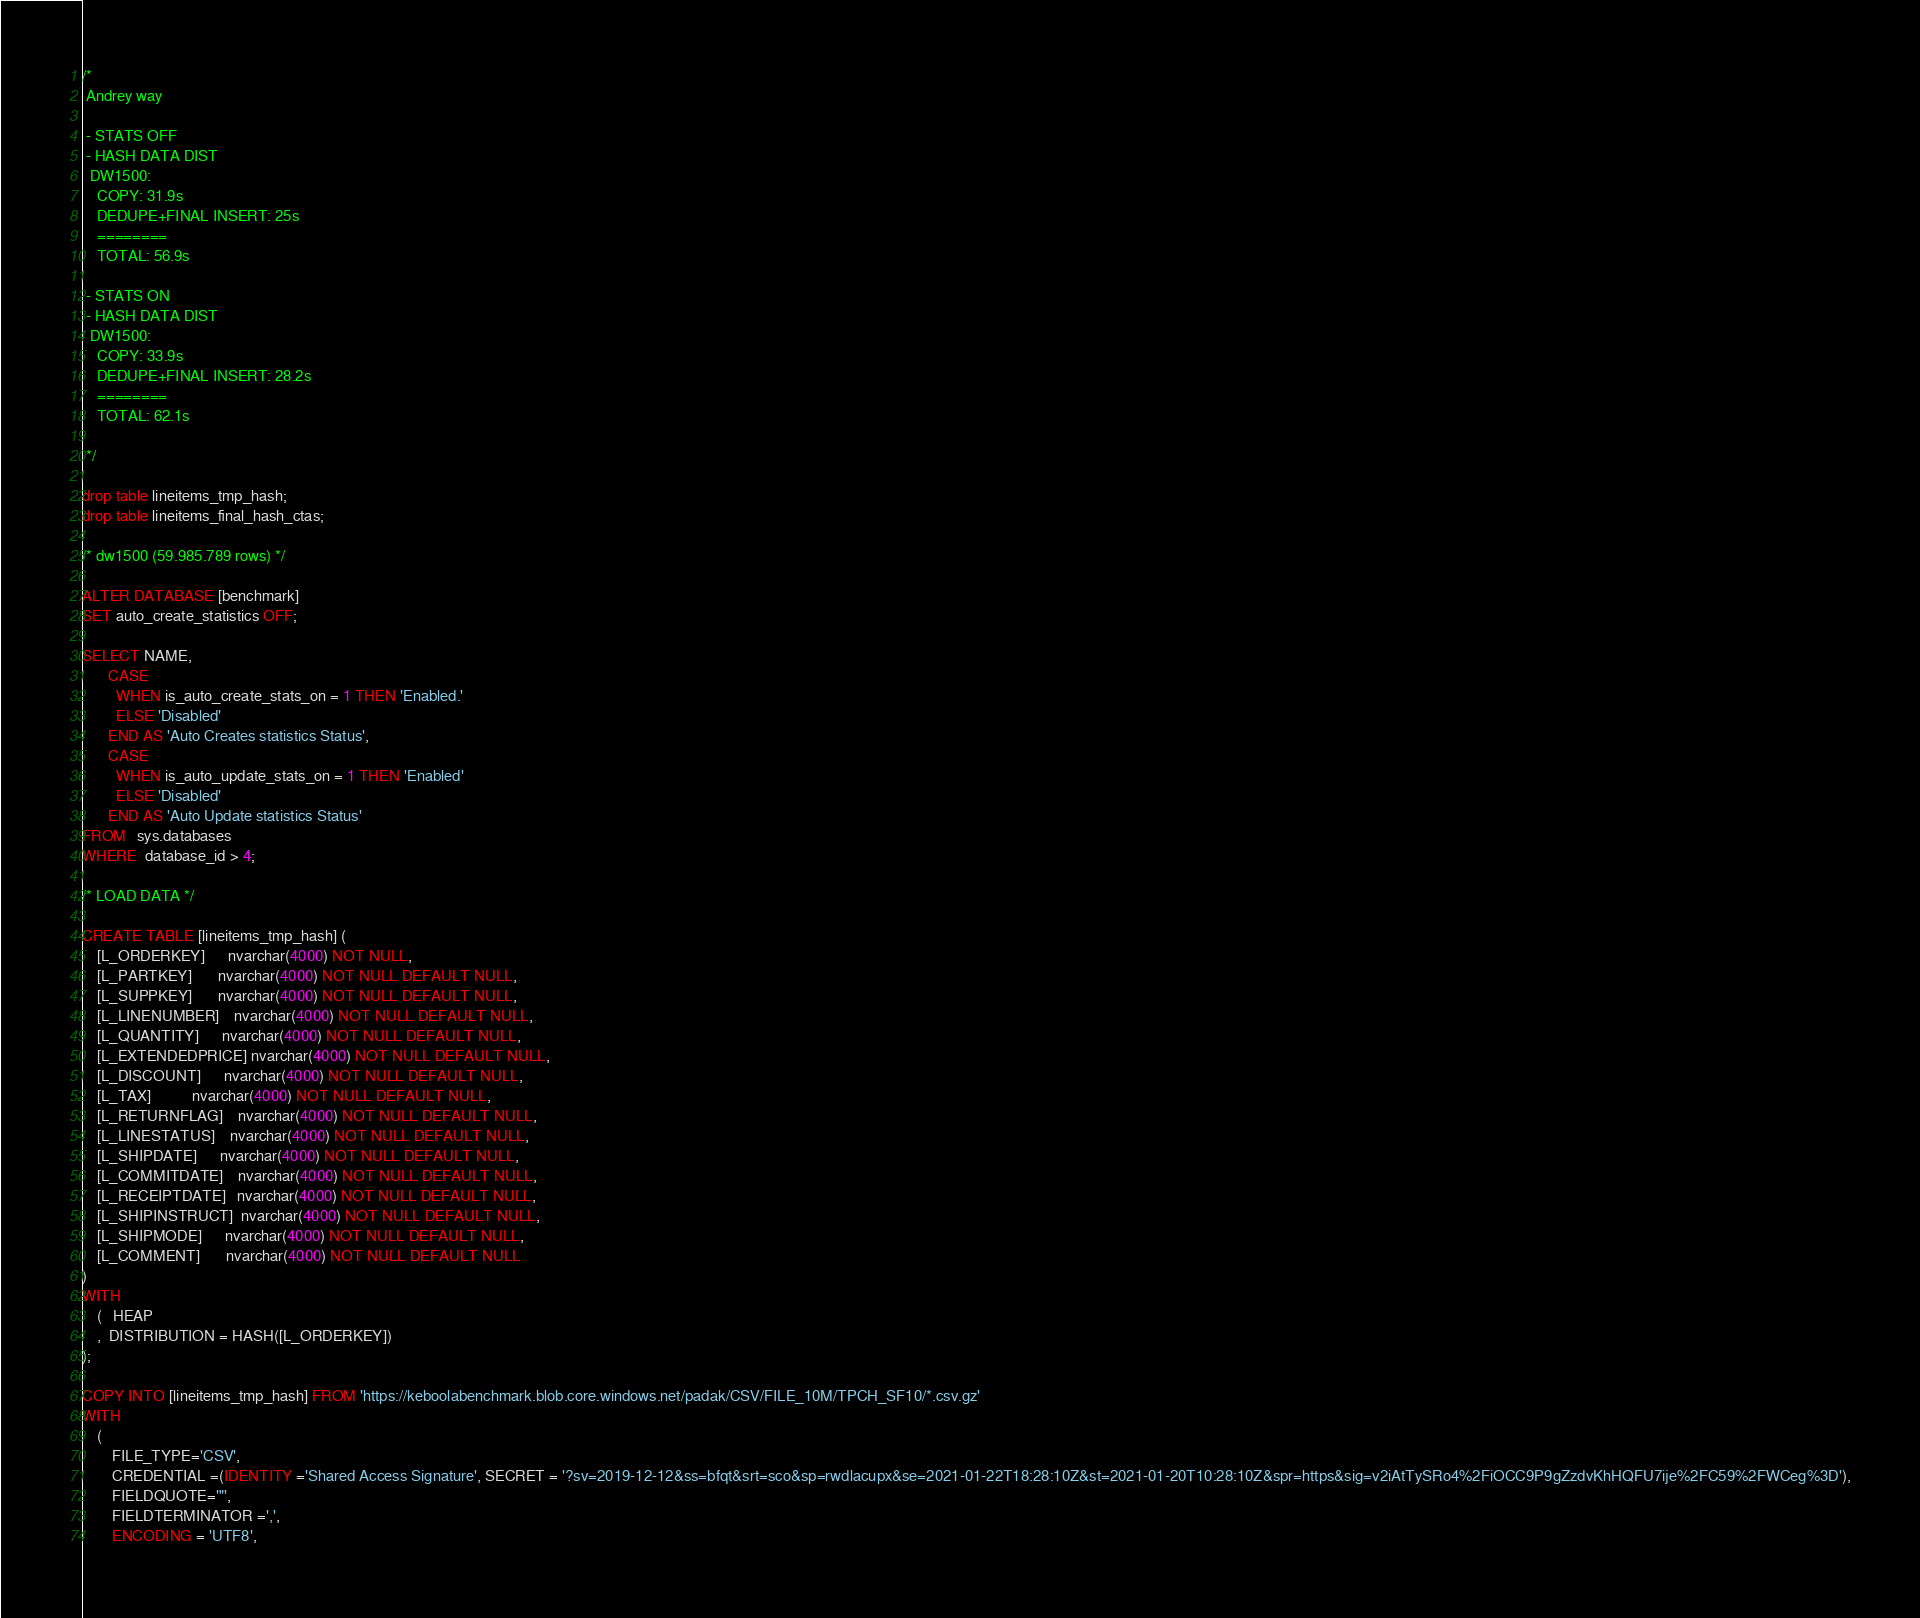Convert code to text. <code><loc_0><loc_0><loc_500><loc_500><_SQL_>/*
 Andrey way

 - STATS OFF
 - HASH DATA DIST
  DW1500: 
    COPY: 31.9s
    DEDUPE+FINAL INSERT: 25s
    ========
    TOTAL: 56.9s

 - STATS ON
 - HASH DATA DIST
  DW1500: 
    COPY: 33.9s
    DEDUPE+FINAL INSERT: 28.2s
    ========
    TOTAL: 62.1s

 */

drop table lineitems_tmp_hash;
drop table lineitems_final_hash_ctas;

/* dw1500 (59.985.789 rows) */

ALTER DATABASE [benchmark]
SET auto_create_statistics OFF;

SELECT NAME,
       CASE
         WHEN is_auto_create_stats_on = 1 THEN 'Enabled.'
         ELSE 'Disabled'
       END AS 'Auto Creates statistics Status',
       CASE
         WHEN is_auto_update_stats_on = 1 THEN 'Enabled'
         ELSE 'Disabled'
       END AS 'Auto Update statistics Status'
FROM   sys.databases
WHERE  database_id > 4;

/* LOAD DATA */

CREATE TABLE [lineitems_tmp_hash] (
    [L_ORDERKEY]      nvarchar(4000) NOT NULL,
    [L_PARTKEY]       nvarchar(4000) NOT NULL DEFAULT NULL,
    [L_SUPPKEY]       nvarchar(4000) NOT NULL DEFAULT NULL,
    [L_LINENUMBER]    nvarchar(4000) NOT NULL DEFAULT NULL,
    [L_QUANTITY]      nvarchar(4000) NOT NULL DEFAULT NULL,
    [L_EXTENDEDPRICE] nvarchar(4000) NOT NULL DEFAULT NULL,
    [L_DISCOUNT]      nvarchar(4000) NOT NULL DEFAULT NULL,
    [L_TAX]           nvarchar(4000) NOT NULL DEFAULT NULL,
    [L_RETURNFLAG]    nvarchar(4000) NOT NULL DEFAULT NULL,
    [L_LINESTATUS]    nvarchar(4000) NOT NULL DEFAULT NULL,
    [L_SHIPDATE]      nvarchar(4000) NOT NULL DEFAULT NULL,
    [L_COMMITDATE]    nvarchar(4000) NOT NULL DEFAULT NULL,
    [L_RECEIPTDATE]   nvarchar(4000) NOT NULL DEFAULT NULL,
    [L_SHIPINSTRUCT]  nvarchar(4000) NOT NULL DEFAULT NULL,
    [L_SHIPMODE]      nvarchar(4000) NOT NULL DEFAULT NULL,
    [L_COMMENT]       nvarchar(4000) NOT NULL DEFAULT NULL
)
WITH
    (   HEAP
    ,  DISTRIBUTION = HASH([L_ORDERKEY])
); 

COPY INTO [lineitems_tmp_hash] FROM 'https://keboolabenchmark.blob.core.windows.net/padak/CSV/FILE_10M/TPCH_SF10/*.csv.gz'
WITH
    (
        FILE_TYPE='CSV',
        CREDENTIAL =(IDENTITY ='Shared Access Signature', SECRET = '?sv=2019-12-12&ss=bfqt&srt=sco&sp=rwdlacupx&se=2021-01-22T18:28:10Z&st=2021-01-20T10:28:10Z&spr=https&sig=v2iAtTySRo4%2FiOCC9P9gZzdvKhHQFU7ije%2FC59%2FWCeg%3D'),
        FIELDQUOTE='"',
        FIELDTERMINATOR =',',
        ENCODING = 'UTF8',</code> 